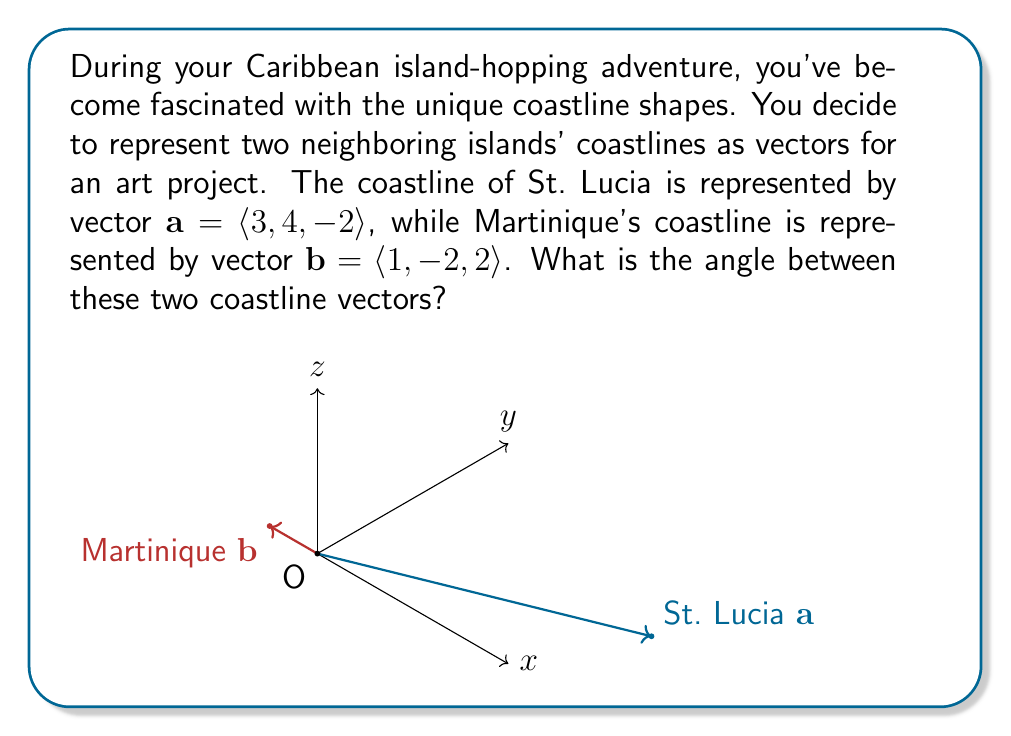Help me with this question. To find the angle between two vectors, we can use the dot product formula:

$$\cos \theta = \frac{\mathbf{a} \cdot \mathbf{b}}{|\mathbf{a}||\mathbf{b}|}$$

Let's solve this step-by-step:

1) First, calculate the dot product $\mathbf{a} \cdot \mathbf{b}$:
   $$\mathbf{a} \cdot \mathbf{b} = (3)(1) + (4)(-2) + (-2)(2) = 3 - 8 - 4 = -9$$

2) Calculate the magnitudes of vectors $\mathbf{a}$ and $\mathbf{b}$:
   $$|\mathbf{a}| = \sqrt{3^2 + 4^2 + (-2)^2} = \sqrt{9 + 16 + 4} = \sqrt{29}$$
   $$|\mathbf{b}| = \sqrt{1^2 + (-2)^2 + 2^2} = \sqrt{1 + 4 + 4} = 3$$

3) Substitute these values into the formula:
   $$\cos \theta = \frac{-9}{\sqrt{29} \cdot 3}$$

4) Simplify:
   $$\cos \theta = \frac{-9}{3\sqrt{29}} = -\frac{3}{\sqrt{29}}$$

5) To find $\theta$, take the inverse cosine (arccos) of both sides:
   $$\theta = \arccos(-\frac{3}{\sqrt{29}})$$

6) Using a calculator, we can evaluate this:
   $$\theta \approx 2.214 \text{ radians}$$

7) Convert to degrees:
   $$\theta \approx 2.214 \cdot \frac{180^{\circ}}{\pi} \approx 126.9^{\circ}$$
Answer: $126.9^{\circ}$ 